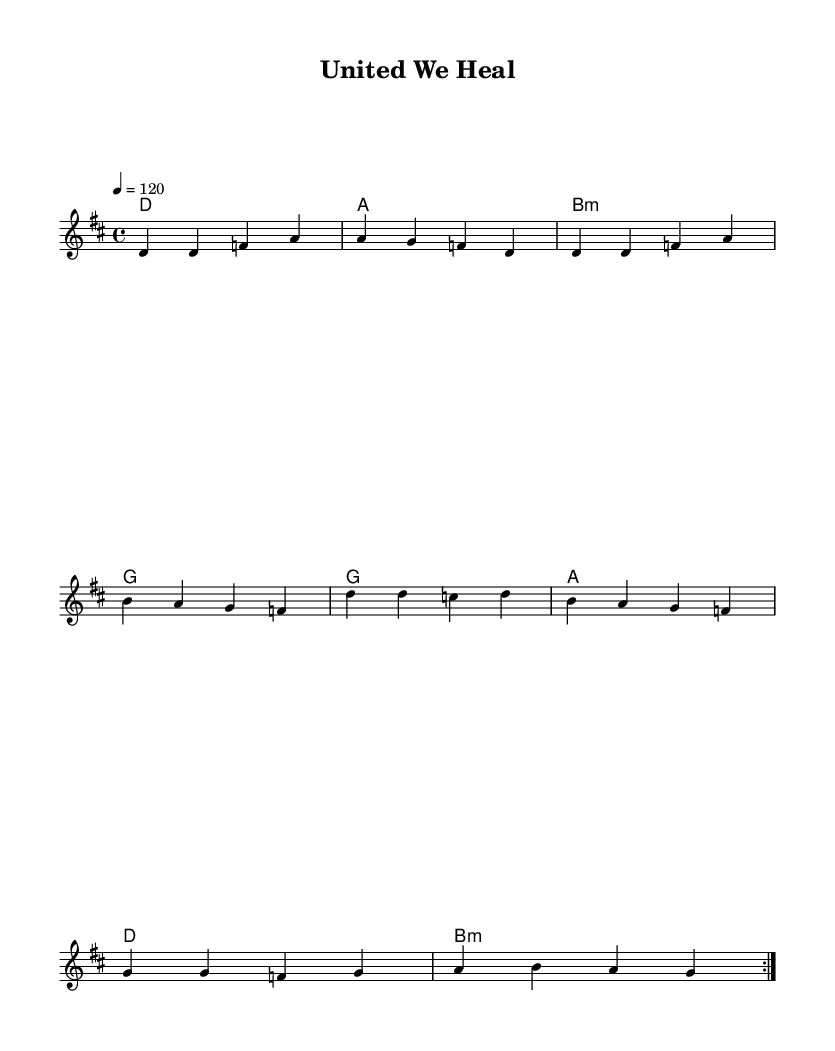What is the key signature of this music? The key signature is indicated at the beginning of the staff. In this case, it is D major, which has two sharps (F# and C#).
Answer: D major What is the time signature of this piece? The time signature is written at the beginning of the score. Here it is 4/4, which means there are four beats per measure.
Answer: 4/4 What is the tempo marking for this song? The tempo is noted with "4 = 120" at the beginning, indicating a quarter note equals a tempo of 120 beats per minute.
Answer: 120 How many measures are in the verse section? The verse section consists of the melodyVerse block, which consists of four measures as indicated by the notation grouped in sets of four beats.
Answer: Four measures What chord follows the D major chord in the harmony section? The chord progression is shown below the melody. After the D major chord, the next chord is A major, which is the next chord in the sequence.
Answer: A What is the last word of the chorus lyrics? The lyrics are provided under the melody lines. The last word of the chorus is "call". By reading the lyrics to the end, "the global call" indicates this clearly.
Answer: call What is the primary theme of the lyrics? The lyrics focus on unity and global cooperation, as the phrases suggest collaboration and support across borders, which can be inferred from both verses and chorus.
Answer: Unity and cooperation 